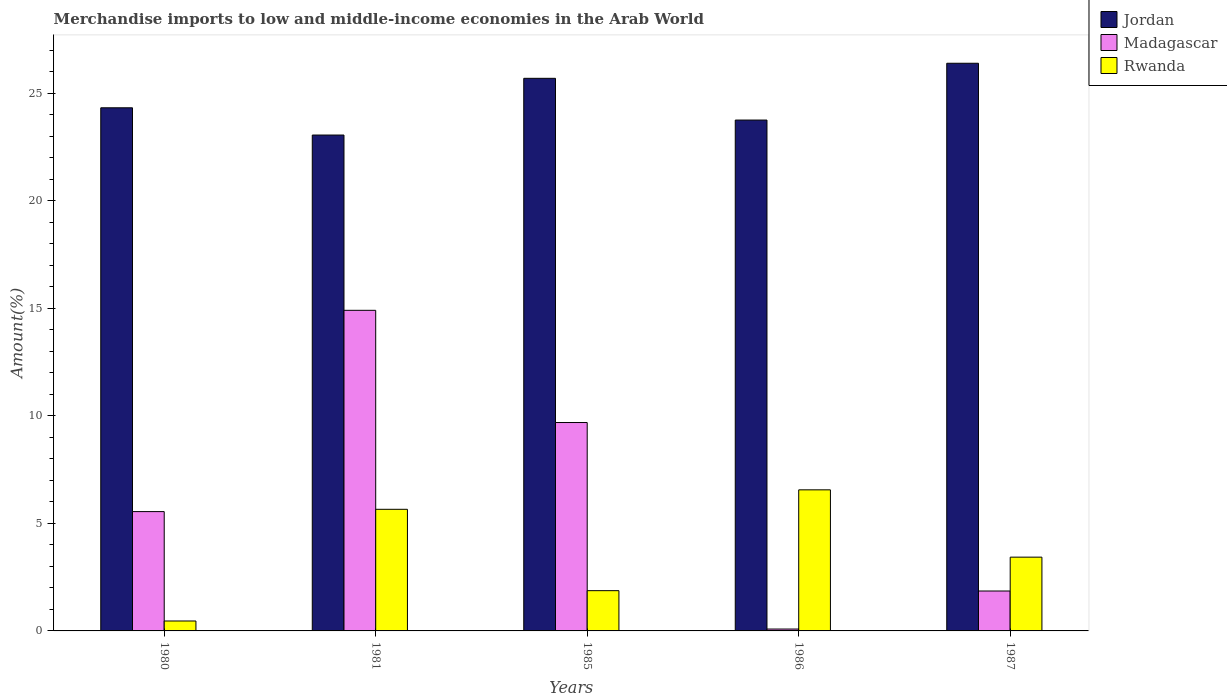Are the number of bars per tick equal to the number of legend labels?
Ensure brevity in your answer.  Yes. Are the number of bars on each tick of the X-axis equal?
Your response must be concise. Yes. How many bars are there on the 2nd tick from the right?
Keep it short and to the point. 3. What is the label of the 1st group of bars from the left?
Provide a succinct answer. 1980. In how many cases, is the number of bars for a given year not equal to the number of legend labels?
Your answer should be compact. 0. What is the percentage of amount earned from merchandise imports in Madagascar in 1985?
Provide a succinct answer. 9.69. Across all years, what is the maximum percentage of amount earned from merchandise imports in Rwanda?
Give a very brief answer. 6.56. Across all years, what is the minimum percentage of amount earned from merchandise imports in Rwanda?
Provide a short and direct response. 0.46. In which year was the percentage of amount earned from merchandise imports in Madagascar maximum?
Offer a terse response. 1981. In which year was the percentage of amount earned from merchandise imports in Rwanda minimum?
Offer a terse response. 1980. What is the total percentage of amount earned from merchandise imports in Rwanda in the graph?
Keep it short and to the point. 17.98. What is the difference between the percentage of amount earned from merchandise imports in Rwanda in 1980 and that in 1986?
Ensure brevity in your answer.  -6.1. What is the difference between the percentage of amount earned from merchandise imports in Jordan in 1986 and the percentage of amount earned from merchandise imports in Rwanda in 1985?
Your answer should be compact. 21.88. What is the average percentage of amount earned from merchandise imports in Madagascar per year?
Ensure brevity in your answer.  6.42. In the year 1986, what is the difference between the percentage of amount earned from merchandise imports in Rwanda and percentage of amount earned from merchandise imports in Madagascar?
Give a very brief answer. 6.47. In how many years, is the percentage of amount earned from merchandise imports in Madagascar greater than 24 %?
Give a very brief answer. 0. What is the ratio of the percentage of amount earned from merchandise imports in Madagascar in 1981 to that in 1986?
Offer a very short reply. 170.28. Is the percentage of amount earned from merchandise imports in Jordan in 1985 less than that in 1987?
Provide a succinct answer. Yes. What is the difference between the highest and the second highest percentage of amount earned from merchandise imports in Jordan?
Your answer should be compact. 0.7. What is the difference between the highest and the lowest percentage of amount earned from merchandise imports in Rwanda?
Offer a terse response. 6.1. In how many years, is the percentage of amount earned from merchandise imports in Madagascar greater than the average percentage of amount earned from merchandise imports in Madagascar taken over all years?
Provide a succinct answer. 2. What does the 3rd bar from the left in 1981 represents?
Make the answer very short. Rwanda. What does the 2nd bar from the right in 1985 represents?
Your response must be concise. Madagascar. Is it the case that in every year, the sum of the percentage of amount earned from merchandise imports in Rwanda and percentage of amount earned from merchandise imports in Madagascar is greater than the percentage of amount earned from merchandise imports in Jordan?
Your answer should be compact. No. How many bars are there?
Give a very brief answer. 15. How many years are there in the graph?
Provide a succinct answer. 5. What is the difference between two consecutive major ticks on the Y-axis?
Make the answer very short. 5. Are the values on the major ticks of Y-axis written in scientific E-notation?
Provide a short and direct response. No. Does the graph contain any zero values?
Keep it short and to the point. No. Does the graph contain grids?
Provide a short and direct response. No. Where does the legend appear in the graph?
Your answer should be very brief. Top right. How many legend labels are there?
Offer a terse response. 3. What is the title of the graph?
Provide a short and direct response. Merchandise imports to low and middle-income economies in the Arab World. What is the label or title of the Y-axis?
Offer a very short reply. Amount(%). What is the Amount(%) in Jordan in 1980?
Ensure brevity in your answer.  24.33. What is the Amount(%) of Madagascar in 1980?
Give a very brief answer. 5.55. What is the Amount(%) of Rwanda in 1980?
Provide a succinct answer. 0.46. What is the Amount(%) in Jordan in 1981?
Keep it short and to the point. 23.06. What is the Amount(%) of Madagascar in 1981?
Make the answer very short. 14.91. What is the Amount(%) of Rwanda in 1981?
Provide a short and direct response. 5.66. What is the Amount(%) of Jordan in 1985?
Offer a very short reply. 25.7. What is the Amount(%) in Madagascar in 1985?
Make the answer very short. 9.69. What is the Amount(%) in Rwanda in 1985?
Provide a succinct answer. 1.87. What is the Amount(%) of Jordan in 1986?
Offer a very short reply. 23.76. What is the Amount(%) of Madagascar in 1986?
Offer a terse response. 0.09. What is the Amount(%) of Rwanda in 1986?
Offer a terse response. 6.56. What is the Amount(%) in Jordan in 1987?
Give a very brief answer. 26.4. What is the Amount(%) of Madagascar in 1987?
Offer a very short reply. 1.86. What is the Amount(%) of Rwanda in 1987?
Offer a terse response. 3.43. Across all years, what is the maximum Amount(%) of Jordan?
Ensure brevity in your answer.  26.4. Across all years, what is the maximum Amount(%) in Madagascar?
Offer a terse response. 14.91. Across all years, what is the maximum Amount(%) of Rwanda?
Keep it short and to the point. 6.56. Across all years, what is the minimum Amount(%) of Jordan?
Provide a short and direct response. 23.06. Across all years, what is the minimum Amount(%) of Madagascar?
Give a very brief answer. 0.09. Across all years, what is the minimum Amount(%) in Rwanda?
Your answer should be very brief. 0.46. What is the total Amount(%) of Jordan in the graph?
Your answer should be compact. 123.24. What is the total Amount(%) in Madagascar in the graph?
Offer a terse response. 32.09. What is the total Amount(%) in Rwanda in the graph?
Your answer should be very brief. 17.98. What is the difference between the Amount(%) in Jordan in 1980 and that in 1981?
Your response must be concise. 1.27. What is the difference between the Amount(%) of Madagascar in 1980 and that in 1981?
Offer a terse response. -9.36. What is the difference between the Amount(%) of Rwanda in 1980 and that in 1981?
Your response must be concise. -5.19. What is the difference between the Amount(%) in Jordan in 1980 and that in 1985?
Your answer should be compact. -1.37. What is the difference between the Amount(%) in Madagascar in 1980 and that in 1985?
Offer a very short reply. -4.14. What is the difference between the Amount(%) in Rwanda in 1980 and that in 1985?
Your answer should be compact. -1.41. What is the difference between the Amount(%) of Jordan in 1980 and that in 1986?
Ensure brevity in your answer.  0.57. What is the difference between the Amount(%) in Madagascar in 1980 and that in 1986?
Your answer should be compact. 5.46. What is the difference between the Amount(%) of Rwanda in 1980 and that in 1986?
Offer a terse response. -6.1. What is the difference between the Amount(%) in Jordan in 1980 and that in 1987?
Offer a very short reply. -2.07. What is the difference between the Amount(%) in Madagascar in 1980 and that in 1987?
Provide a succinct answer. 3.69. What is the difference between the Amount(%) of Rwanda in 1980 and that in 1987?
Provide a short and direct response. -2.97. What is the difference between the Amount(%) in Jordan in 1981 and that in 1985?
Keep it short and to the point. -2.64. What is the difference between the Amount(%) in Madagascar in 1981 and that in 1985?
Offer a very short reply. 5.22. What is the difference between the Amount(%) of Rwanda in 1981 and that in 1985?
Your response must be concise. 3.78. What is the difference between the Amount(%) of Jordan in 1981 and that in 1986?
Provide a short and direct response. -0.7. What is the difference between the Amount(%) in Madagascar in 1981 and that in 1986?
Give a very brief answer. 14.82. What is the difference between the Amount(%) of Rwanda in 1981 and that in 1986?
Your answer should be compact. -0.91. What is the difference between the Amount(%) of Jordan in 1981 and that in 1987?
Your answer should be compact. -3.34. What is the difference between the Amount(%) of Madagascar in 1981 and that in 1987?
Offer a very short reply. 13.05. What is the difference between the Amount(%) of Rwanda in 1981 and that in 1987?
Provide a short and direct response. 2.23. What is the difference between the Amount(%) in Jordan in 1985 and that in 1986?
Provide a short and direct response. 1.94. What is the difference between the Amount(%) in Madagascar in 1985 and that in 1986?
Your response must be concise. 9.6. What is the difference between the Amount(%) of Rwanda in 1985 and that in 1986?
Give a very brief answer. -4.69. What is the difference between the Amount(%) of Jordan in 1985 and that in 1987?
Keep it short and to the point. -0.7. What is the difference between the Amount(%) in Madagascar in 1985 and that in 1987?
Ensure brevity in your answer.  7.83. What is the difference between the Amount(%) in Rwanda in 1985 and that in 1987?
Make the answer very short. -1.56. What is the difference between the Amount(%) of Jordan in 1986 and that in 1987?
Ensure brevity in your answer.  -2.64. What is the difference between the Amount(%) in Madagascar in 1986 and that in 1987?
Provide a succinct answer. -1.77. What is the difference between the Amount(%) of Rwanda in 1986 and that in 1987?
Make the answer very short. 3.13. What is the difference between the Amount(%) of Jordan in 1980 and the Amount(%) of Madagascar in 1981?
Ensure brevity in your answer.  9.42. What is the difference between the Amount(%) in Jordan in 1980 and the Amount(%) in Rwanda in 1981?
Provide a short and direct response. 18.67. What is the difference between the Amount(%) in Madagascar in 1980 and the Amount(%) in Rwanda in 1981?
Offer a terse response. -0.11. What is the difference between the Amount(%) in Jordan in 1980 and the Amount(%) in Madagascar in 1985?
Offer a terse response. 14.64. What is the difference between the Amount(%) of Jordan in 1980 and the Amount(%) of Rwanda in 1985?
Offer a terse response. 22.45. What is the difference between the Amount(%) in Madagascar in 1980 and the Amount(%) in Rwanda in 1985?
Provide a short and direct response. 3.68. What is the difference between the Amount(%) of Jordan in 1980 and the Amount(%) of Madagascar in 1986?
Your response must be concise. 24.24. What is the difference between the Amount(%) in Jordan in 1980 and the Amount(%) in Rwanda in 1986?
Provide a succinct answer. 17.77. What is the difference between the Amount(%) in Madagascar in 1980 and the Amount(%) in Rwanda in 1986?
Your answer should be compact. -1.01. What is the difference between the Amount(%) of Jordan in 1980 and the Amount(%) of Madagascar in 1987?
Give a very brief answer. 22.47. What is the difference between the Amount(%) of Jordan in 1980 and the Amount(%) of Rwanda in 1987?
Give a very brief answer. 20.9. What is the difference between the Amount(%) in Madagascar in 1980 and the Amount(%) in Rwanda in 1987?
Offer a terse response. 2.12. What is the difference between the Amount(%) of Jordan in 1981 and the Amount(%) of Madagascar in 1985?
Ensure brevity in your answer.  13.37. What is the difference between the Amount(%) in Jordan in 1981 and the Amount(%) in Rwanda in 1985?
Provide a short and direct response. 21.19. What is the difference between the Amount(%) of Madagascar in 1981 and the Amount(%) of Rwanda in 1985?
Your response must be concise. 13.04. What is the difference between the Amount(%) in Jordan in 1981 and the Amount(%) in Madagascar in 1986?
Offer a very short reply. 22.97. What is the difference between the Amount(%) in Jordan in 1981 and the Amount(%) in Rwanda in 1986?
Offer a very short reply. 16.5. What is the difference between the Amount(%) in Madagascar in 1981 and the Amount(%) in Rwanda in 1986?
Provide a succinct answer. 8.35. What is the difference between the Amount(%) in Jordan in 1981 and the Amount(%) in Madagascar in 1987?
Offer a very short reply. 21.2. What is the difference between the Amount(%) of Jordan in 1981 and the Amount(%) of Rwanda in 1987?
Your response must be concise. 19.63. What is the difference between the Amount(%) in Madagascar in 1981 and the Amount(%) in Rwanda in 1987?
Your response must be concise. 11.48. What is the difference between the Amount(%) in Jordan in 1985 and the Amount(%) in Madagascar in 1986?
Your answer should be compact. 25.61. What is the difference between the Amount(%) of Jordan in 1985 and the Amount(%) of Rwanda in 1986?
Provide a succinct answer. 19.14. What is the difference between the Amount(%) of Madagascar in 1985 and the Amount(%) of Rwanda in 1986?
Your answer should be very brief. 3.13. What is the difference between the Amount(%) in Jordan in 1985 and the Amount(%) in Madagascar in 1987?
Provide a succinct answer. 23.84. What is the difference between the Amount(%) in Jordan in 1985 and the Amount(%) in Rwanda in 1987?
Provide a short and direct response. 22.27. What is the difference between the Amount(%) of Madagascar in 1985 and the Amount(%) of Rwanda in 1987?
Make the answer very short. 6.26. What is the difference between the Amount(%) in Jordan in 1986 and the Amount(%) in Madagascar in 1987?
Give a very brief answer. 21.9. What is the difference between the Amount(%) of Jordan in 1986 and the Amount(%) of Rwanda in 1987?
Ensure brevity in your answer.  20.33. What is the difference between the Amount(%) of Madagascar in 1986 and the Amount(%) of Rwanda in 1987?
Offer a terse response. -3.34. What is the average Amount(%) of Jordan per year?
Offer a terse response. 24.65. What is the average Amount(%) in Madagascar per year?
Provide a short and direct response. 6.42. What is the average Amount(%) in Rwanda per year?
Your answer should be very brief. 3.6. In the year 1980, what is the difference between the Amount(%) of Jordan and Amount(%) of Madagascar?
Your response must be concise. 18.78. In the year 1980, what is the difference between the Amount(%) in Jordan and Amount(%) in Rwanda?
Keep it short and to the point. 23.87. In the year 1980, what is the difference between the Amount(%) of Madagascar and Amount(%) of Rwanda?
Your response must be concise. 5.09. In the year 1981, what is the difference between the Amount(%) of Jordan and Amount(%) of Madagascar?
Provide a succinct answer. 8.15. In the year 1981, what is the difference between the Amount(%) in Jordan and Amount(%) in Rwanda?
Give a very brief answer. 17.4. In the year 1981, what is the difference between the Amount(%) of Madagascar and Amount(%) of Rwanda?
Make the answer very short. 9.25. In the year 1985, what is the difference between the Amount(%) in Jordan and Amount(%) in Madagascar?
Your answer should be compact. 16.01. In the year 1985, what is the difference between the Amount(%) in Jordan and Amount(%) in Rwanda?
Make the answer very short. 23.83. In the year 1985, what is the difference between the Amount(%) of Madagascar and Amount(%) of Rwanda?
Keep it short and to the point. 7.82. In the year 1986, what is the difference between the Amount(%) in Jordan and Amount(%) in Madagascar?
Offer a terse response. 23.67. In the year 1986, what is the difference between the Amount(%) in Jordan and Amount(%) in Rwanda?
Make the answer very short. 17.2. In the year 1986, what is the difference between the Amount(%) of Madagascar and Amount(%) of Rwanda?
Make the answer very short. -6.47. In the year 1987, what is the difference between the Amount(%) of Jordan and Amount(%) of Madagascar?
Your answer should be compact. 24.54. In the year 1987, what is the difference between the Amount(%) in Jordan and Amount(%) in Rwanda?
Ensure brevity in your answer.  22.97. In the year 1987, what is the difference between the Amount(%) of Madagascar and Amount(%) of Rwanda?
Give a very brief answer. -1.57. What is the ratio of the Amount(%) of Jordan in 1980 to that in 1981?
Provide a short and direct response. 1.05. What is the ratio of the Amount(%) of Madagascar in 1980 to that in 1981?
Make the answer very short. 0.37. What is the ratio of the Amount(%) of Rwanda in 1980 to that in 1981?
Your response must be concise. 0.08. What is the ratio of the Amount(%) of Jordan in 1980 to that in 1985?
Offer a very short reply. 0.95. What is the ratio of the Amount(%) in Madagascar in 1980 to that in 1985?
Provide a short and direct response. 0.57. What is the ratio of the Amount(%) of Rwanda in 1980 to that in 1985?
Provide a succinct answer. 0.25. What is the ratio of the Amount(%) in Madagascar in 1980 to that in 1986?
Keep it short and to the point. 63.38. What is the ratio of the Amount(%) in Rwanda in 1980 to that in 1986?
Your response must be concise. 0.07. What is the ratio of the Amount(%) of Jordan in 1980 to that in 1987?
Make the answer very short. 0.92. What is the ratio of the Amount(%) in Madagascar in 1980 to that in 1987?
Make the answer very short. 2.99. What is the ratio of the Amount(%) in Rwanda in 1980 to that in 1987?
Make the answer very short. 0.13. What is the ratio of the Amount(%) in Jordan in 1981 to that in 1985?
Ensure brevity in your answer.  0.9. What is the ratio of the Amount(%) in Madagascar in 1981 to that in 1985?
Offer a terse response. 1.54. What is the ratio of the Amount(%) of Rwanda in 1981 to that in 1985?
Ensure brevity in your answer.  3.02. What is the ratio of the Amount(%) in Jordan in 1981 to that in 1986?
Make the answer very short. 0.97. What is the ratio of the Amount(%) of Madagascar in 1981 to that in 1986?
Offer a very short reply. 170.28. What is the ratio of the Amount(%) of Rwanda in 1981 to that in 1986?
Your answer should be very brief. 0.86. What is the ratio of the Amount(%) of Jordan in 1981 to that in 1987?
Keep it short and to the point. 0.87. What is the ratio of the Amount(%) in Madagascar in 1981 to that in 1987?
Offer a very short reply. 8.03. What is the ratio of the Amount(%) in Rwanda in 1981 to that in 1987?
Ensure brevity in your answer.  1.65. What is the ratio of the Amount(%) of Jordan in 1985 to that in 1986?
Your response must be concise. 1.08. What is the ratio of the Amount(%) in Madagascar in 1985 to that in 1986?
Provide a short and direct response. 110.68. What is the ratio of the Amount(%) of Rwanda in 1985 to that in 1986?
Your answer should be compact. 0.29. What is the ratio of the Amount(%) of Jordan in 1985 to that in 1987?
Keep it short and to the point. 0.97. What is the ratio of the Amount(%) of Madagascar in 1985 to that in 1987?
Make the answer very short. 5.22. What is the ratio of the Amount(%) in Rwanda in 1985 to that in 1987?
Your answer should be very brief. 0.55. What is the ratio of the Amount(%) in Jordan in 1986 to that in 1987?
Offer a very short reply. 0.9. What is the ratio of the Amount(%) of Madagascar in 1986 to that in 1987?
Provide a succinct answer. 0.05. What is the ratio of the Amount(%) of Rwanda in 1986 to that in 1987?
Offer a terse response. 1.91. What is the difference between the highest and the second highest Amount(%) of Jordan?
Provide a short and direct response. 0.7. What is the difference between the highest and the second highest Amount(%) of Madagascar?
Make the answer very short. 5.22. What is the difference between the highest and the second highest Amount(%) in Rwanda?
Your answer should be very brief. 0.91. What is the difference between the highest and the lowest Amount(%) in Jordan?
Offer a terse response. 3.34. What is the difference between the highest and the lowest Amount(%) of Madagascar?
Provide a succinct answer. 14.82. What is the difference between the highest and the lowest Amount(%) of Rwanda?
Your answer should be compact. 6.1. 